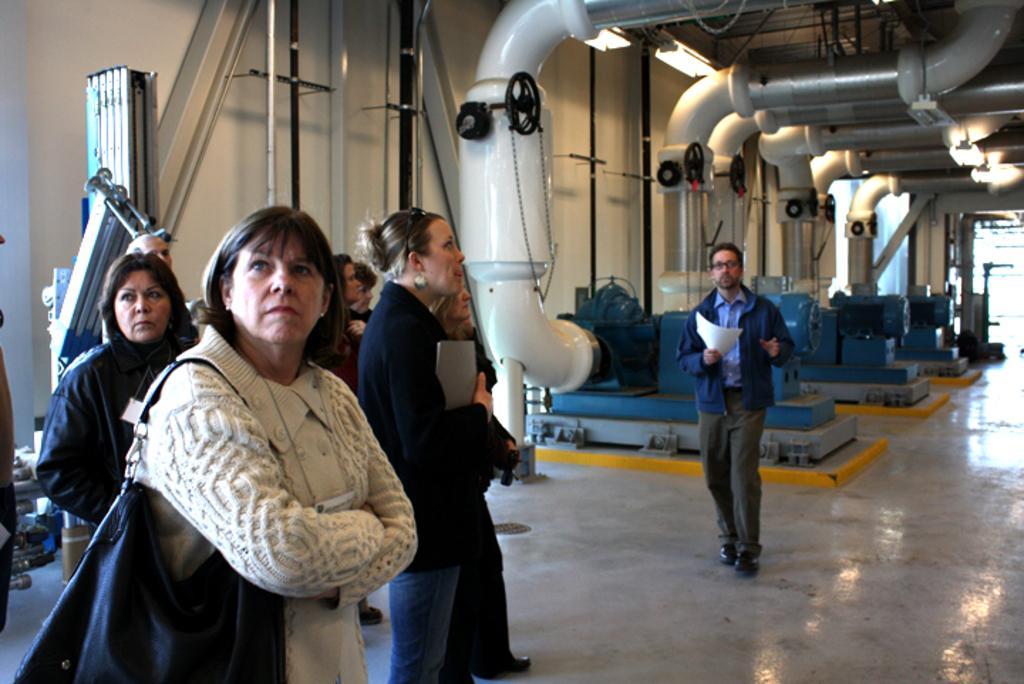Describe this image in one or two sentences. In this picture we can observe some people standing. There are women and a man. In the background we can observe machinery which is in white, blue and black color. There are lights fixed to the ceiling. We can observe a wall here. 